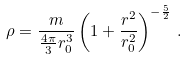Convert formula to latex. <formula><loc_0><loc_0><loc_500><loc_500>\rho = \frac { m } { \frac { 4 \pi } { 3 } r _ { 0 } ^ { 3 } } \left ( 1 + \frac { r ^ { 2 } } { r _ { 0 } ^ { 2 } } \right ) ^ { - \frac { 5 } { 2 } } \, .</formula> 